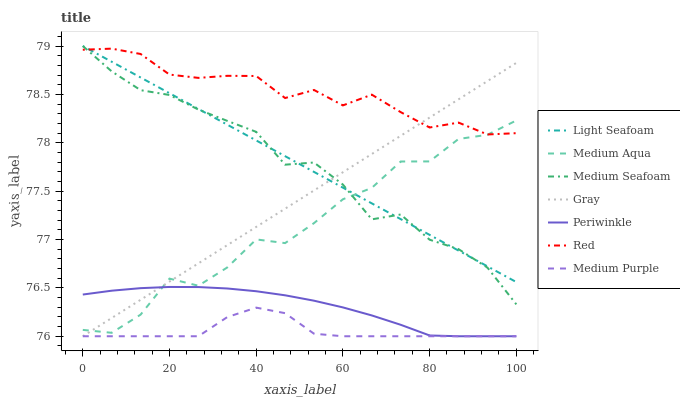Does Medium Purple have the minimum area under the curve?
Answer yes or no. Yes. Does Red have the maximum area under the curve?
Answer yes or no. Yes. Does Periwinkle have the minimum area under the curve?
Answer yes or no. No. Does Periwinkle have the maximum area under the curve?
Answer yes or no. No. Is Light Seafoam the smoothest?
Answer yes or no. Yes. Is Medium Aqua the roughest?
Answer yes or no. Yes. Is Medium Purple the smoothest?
Answer yes or no. No. Is Medium Purple the roughest?
Answer yes or no. No. Does Medium Aqua have the lowest value?
Answer yes or no. No. Does Medium Seafoam have the highest value?
Answer yes or no. Yes. Does Periwinkle have the highest value?
Answer yes or no. No. Is Periwinkle less than Medium Seafoam?
Answer yes or no. Yes. Is Red greater than Medium Purple?
Answer yes or no. Yes. Does Periwinkle intersect Medium Seafoam?
Answer yes or no. No. 